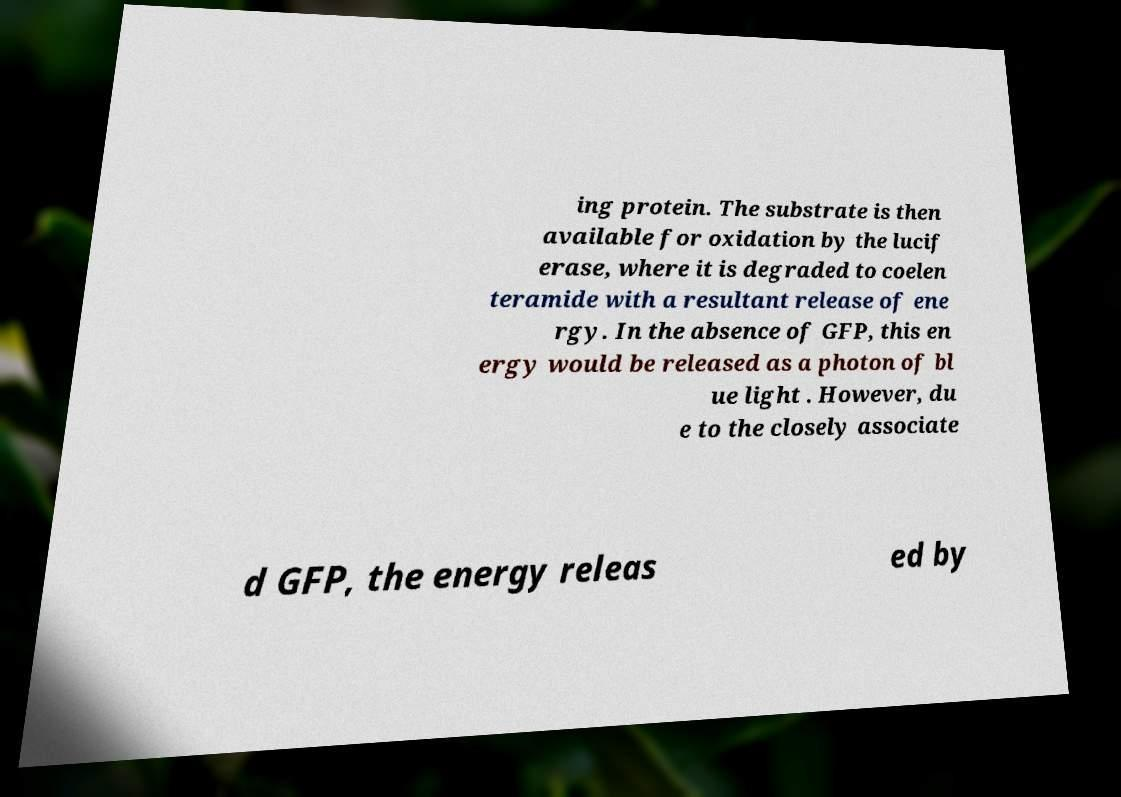Please read and relay the text visible in this image. What does it say? ing protein. The substrate is then available for oxidation by the lucif erase, where it is degraded to coelen teramide with a resultant release of ene rgy. In the absence of GFP, this en ergy would be released as a photon of bl ue light . However, du e to the closely associate d GFP, the energy releas ed by 